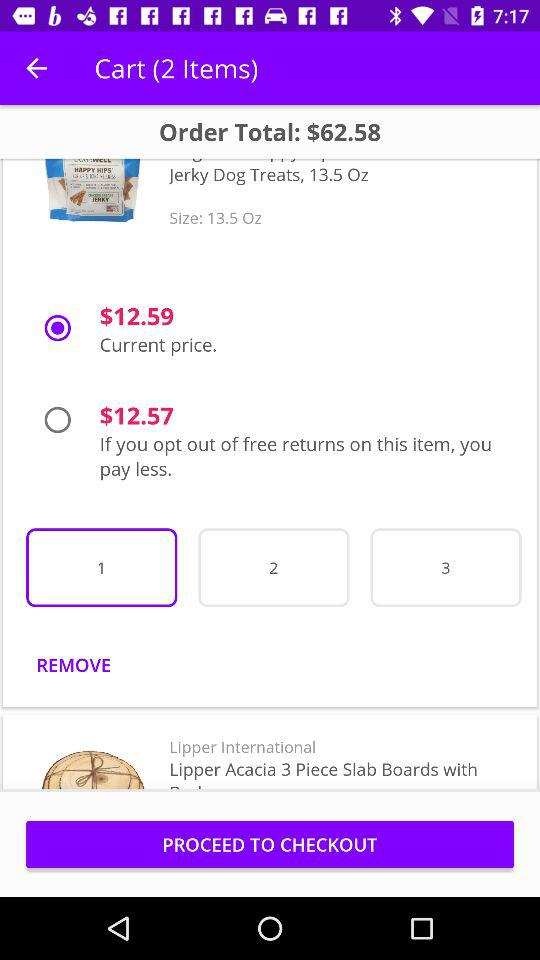How many items are in my cart?
Answer the question using a single word or phrase. 2 